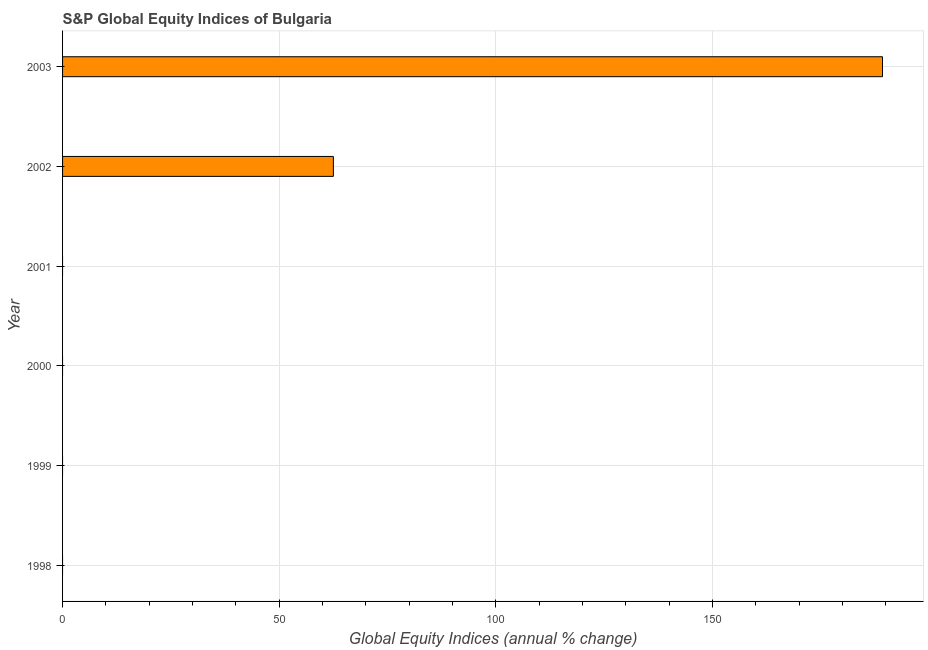Does the graph contain any zero values?
Provide a short and direct response. Yes. What is the title of the graph?
Make the answer very short. S&P Global Equity Indices of Bulgaria. What is the label or title of the X-axis?
Your answer should be compact. Global Equity Indices (annual % change). What is the s&p global equity indices in 2000?
Your answer should be very brief. 0. Across all years, what is the maximum s&p global equity indices?
Give a very brief answer. 189.23. What is the sum of the s&p global equity indices?
Give a very brief answer. 251.73. What is the difference between the s&p global equity indices in 2002 and 2003?
Your answer should be very brief. -126.73. What is the average s&p global equity indices per year?
Keep it short and to the point. 41.95. In how many years, is the s&p global equity indices greater than 40 %?
Give a very brief answer. 2. What is the ratio of the s&p global equity indices in 2002 to that in 2003?
Give a very brief answer. 0.33. Is the s&p global equity indices in 2002 less than that in 2003?
Make the answer very short. Yes. What is the difference between the highest and the lowest s&p global equity indices?
Give a very brief answer. 189.23. How many bars are there?
Give a very brief answer. 2. What is the difference between two consecutive major ticks on the X-axis?
Offer a very short reply. 50. Are the values on the major ticks of X-axis written in scientific E-notation?
Ensure brevity in your answer.  No. What is the Global Equity Indices (annual % change) of 1998?
Give a very brief answer. 0. What is the Global Equity Indices (annual % change) of 2000?
Your answer should be compact. 0. What is the Global Equity Indices (annual % change) in 2001?
Your response must be concise. 0. What is the Global Equity Indices (annual % change) of 2002?
Provide a short and direct response. 62.5. What is the Global Equity Indices (annual % change) in 2003?
Your answer should be very brief. 189.23. What is the difference between the Global Equity Indices (annual % change) in 2002 and 2003?
Ensure brevity in your answer.  -126.73. What is the ratio of the Global Equity Indices (annual % change) in 2002 to that in 2003?
Your answer should be very brief. 0.33. 